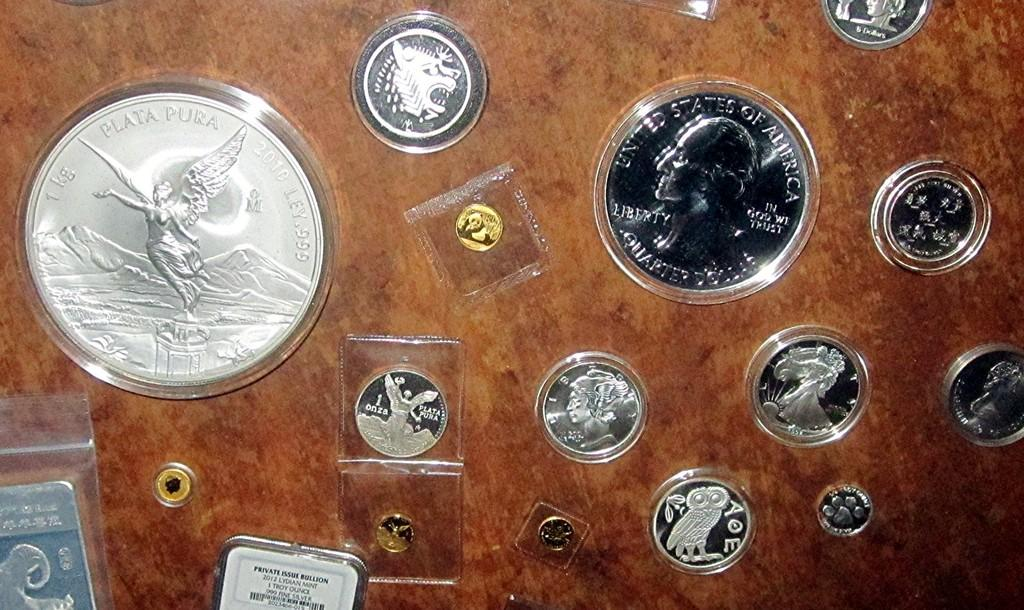What objects can be seen in the image? There are coins in the image. What color is the background of the image? The background of the image is brown. What type of cart is visible in the image? There is no cart present in the image; it only features coins and a brown background. 